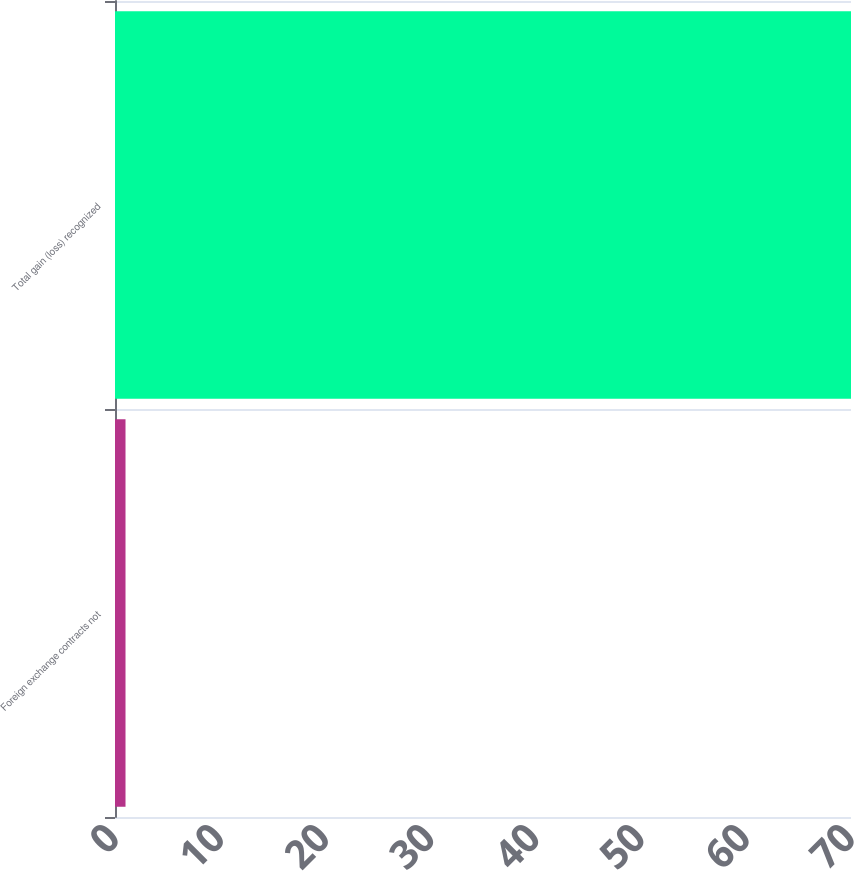Convert chart to OTSL. <chart><loc_0><loc_0><loc_500><loc_500><bar_chart><fcel>Foreign exchange contracts not<fcel>Total gain (loss) recognized<nl><fcel>1<fcel>70<nl></chart> 